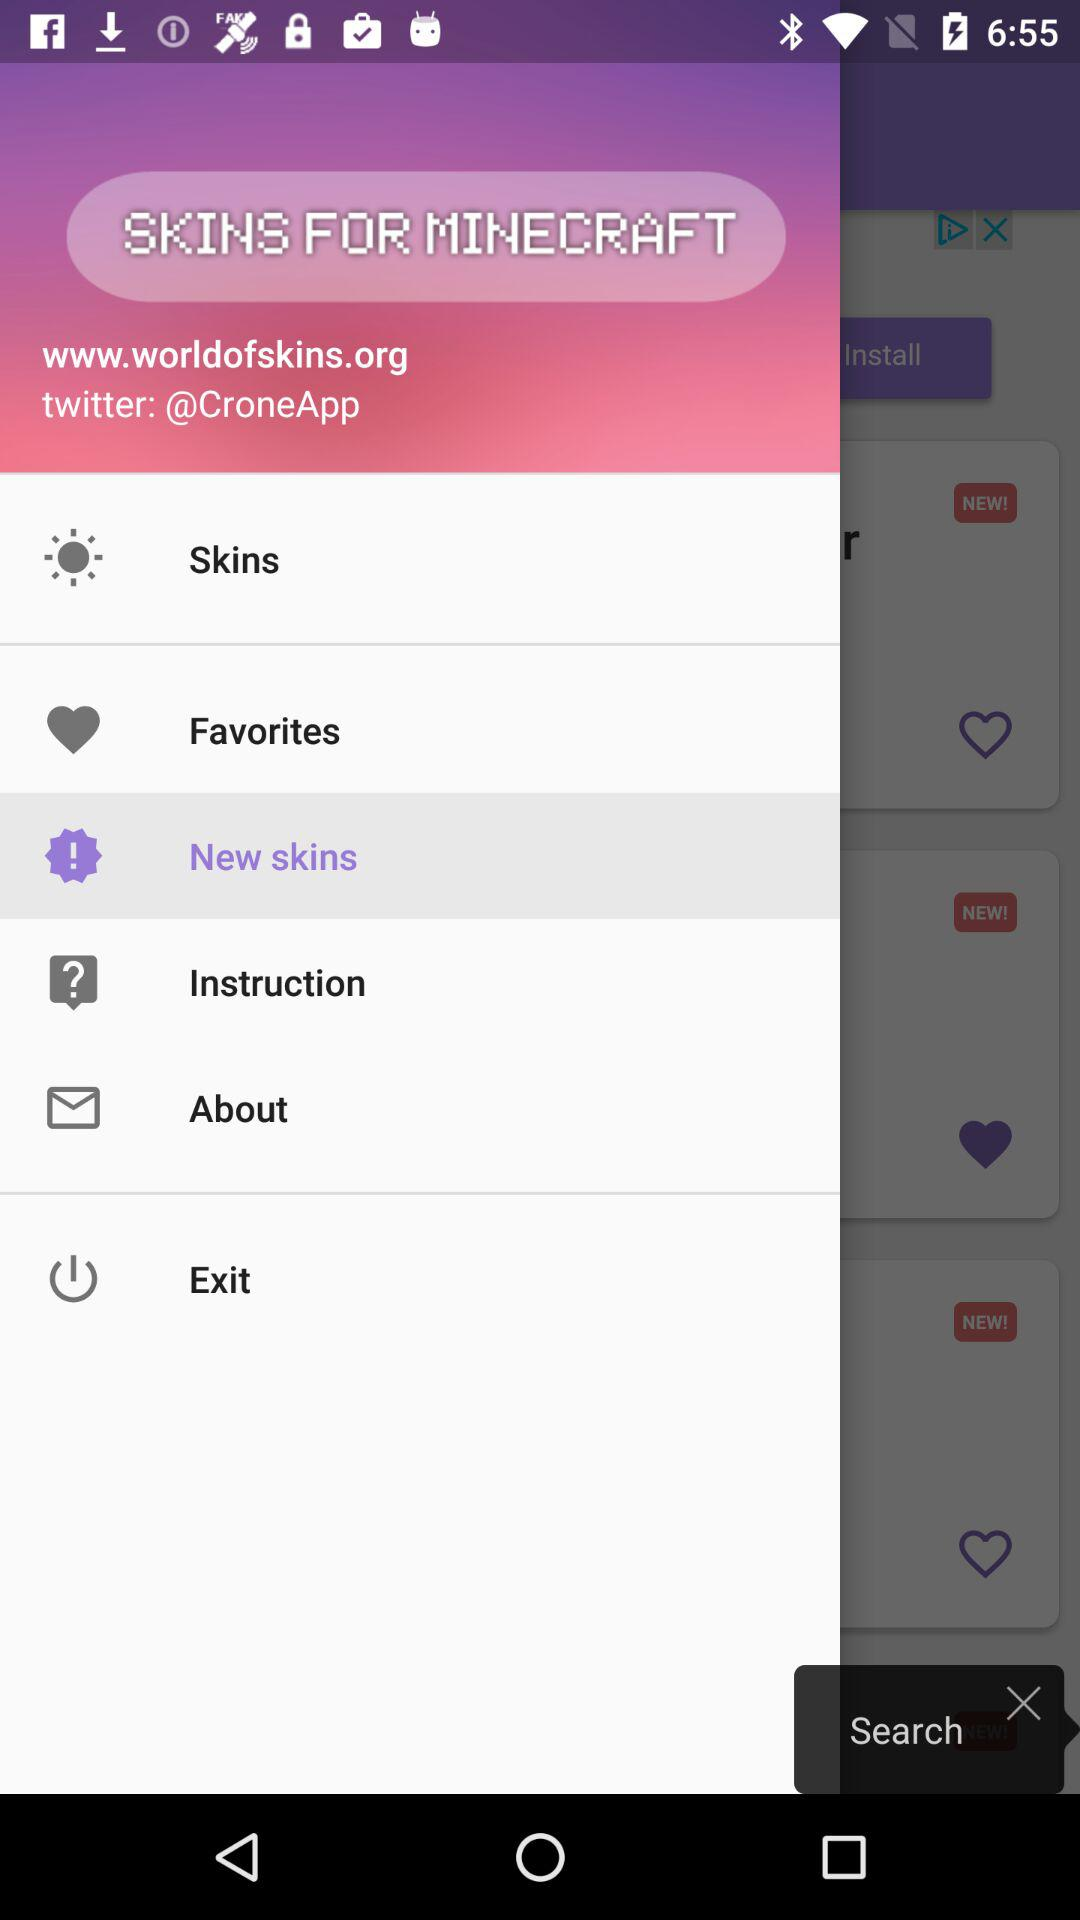What is the Twitter handle? The Twitter handle is "@CroneApp". 